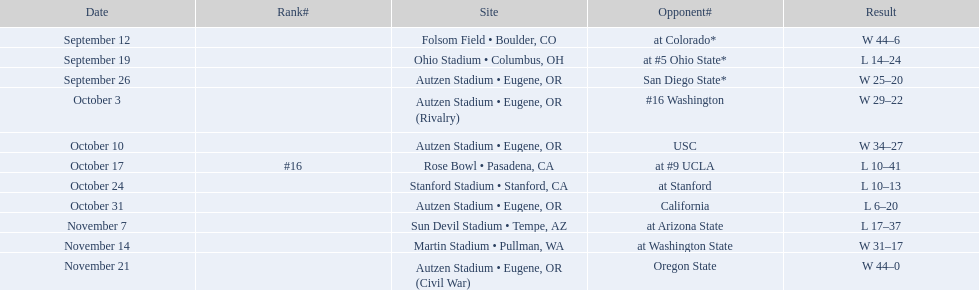What is the number of away games ? 6. 